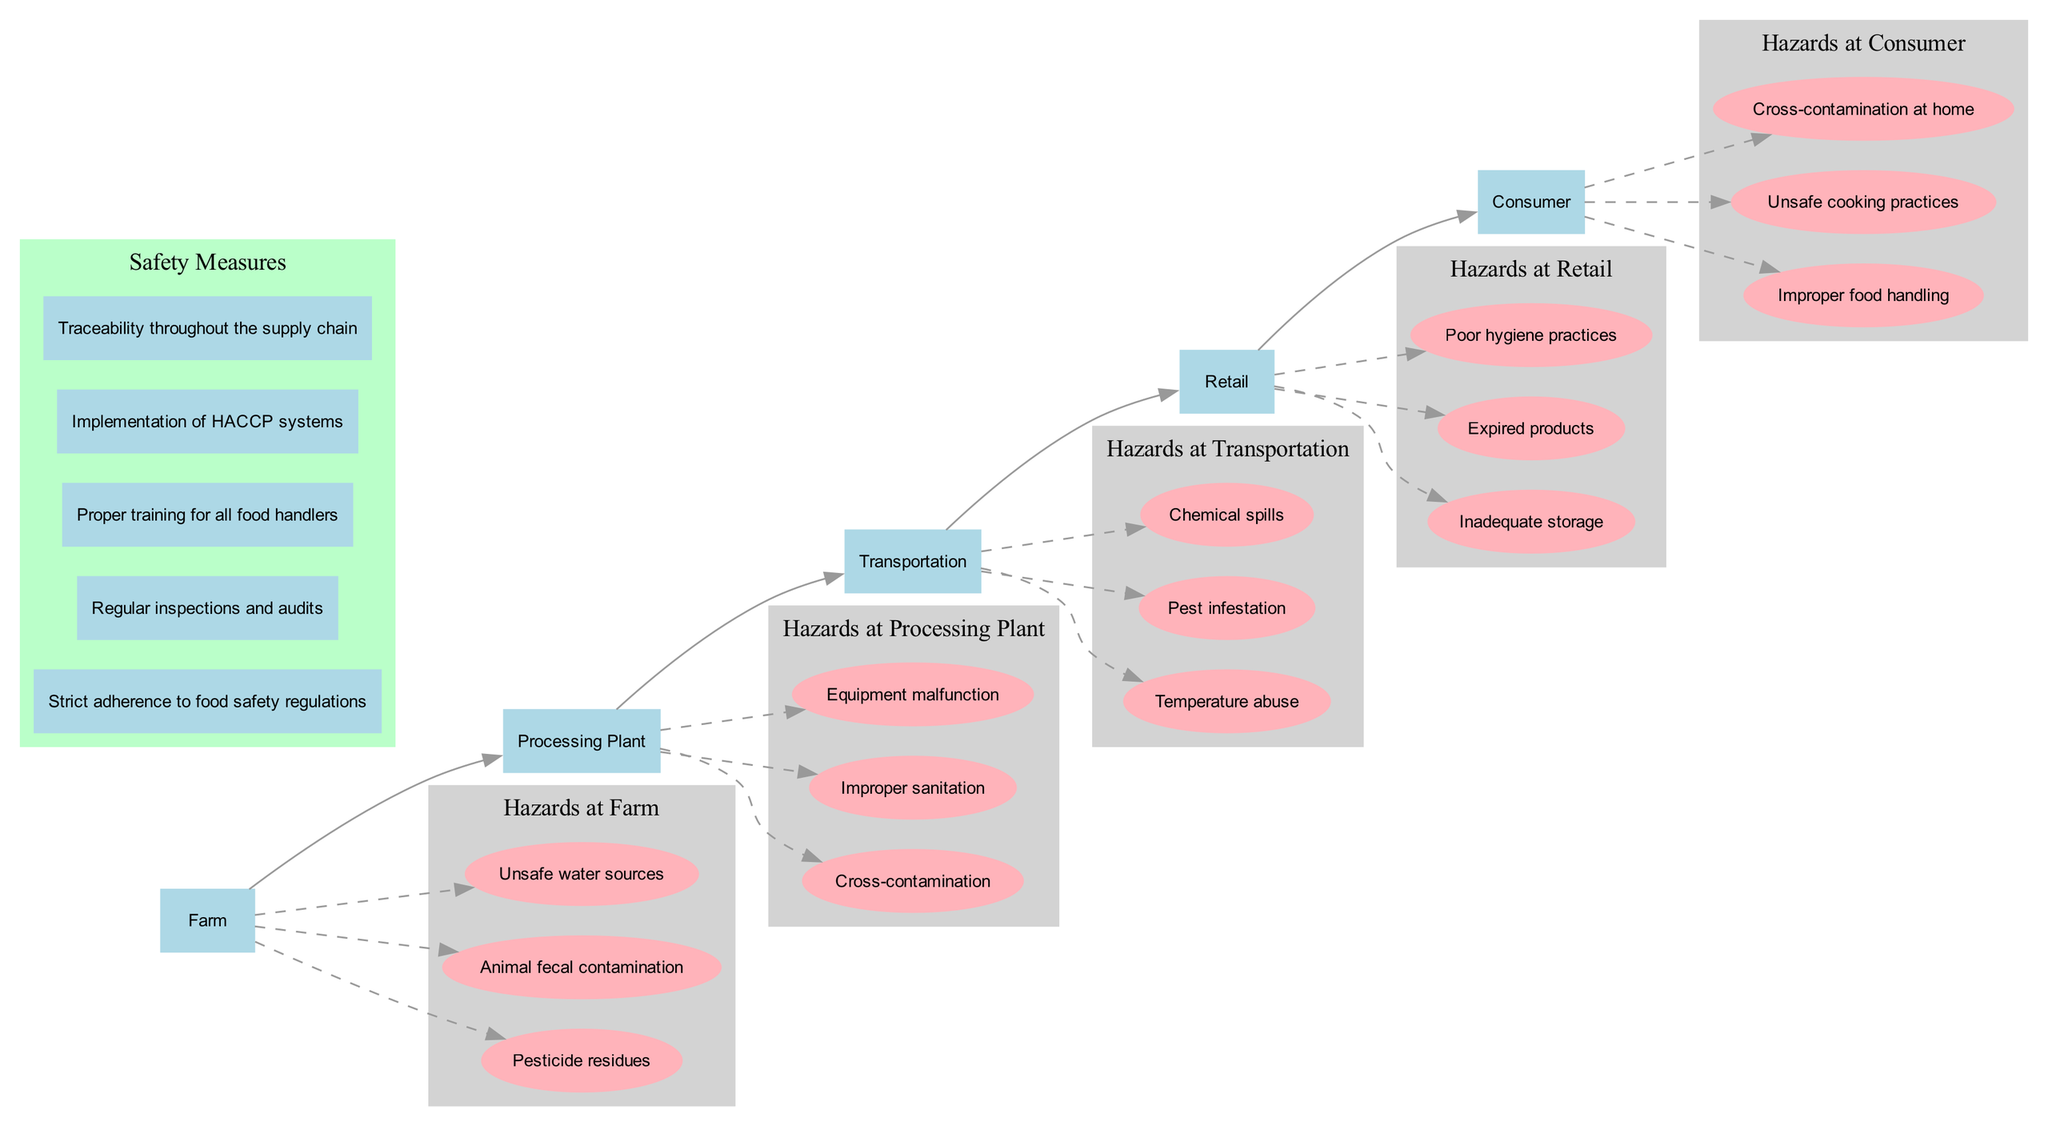What are the stages in the food supply chain? The diagram lists five stages of the food supply chain: Farm, Processing Plant, Transportation, Retail, and Consumer. These stages are shown in sequential order, representing the flow from production to consumption.
Answer: Farm, Processing Plant, Transportation, Retail, Consumer How many hazards are listed for the Transportation stage? There are three specific hazards associated with the Transportation stage: Temperature abuse, Pest infestation, and Chemical spills. The diagram clearly indicates these risks beneath the Transportation stage node.
Answer: Three What risk is associated with the Processing Plant stage? One of the highlighted risks for the Processing Plant stage is Cross-contamination. This hazard is outlined specifically as part of the processing risks.
Answer: Cross-contamination Which stage has the risk of Animal fecal contamination? The risk of Animal fecal contamination is identified as a hazard at the Farm stage, indicating contamination that may occur during the initial production of food.
Answer: Farm What is one safety measure mentioned in the diagram? One noted safety measure is "Strict adherence to food safety regulations." This measure is emphasized in a separate cluster labeled "Safety Measures" in the diagram.
Answer: Strict adherence to food safety regulations Are there any hazards listed for the Consumer stage? Yes, there are risks identified for the Consumer stage, including Improper food handling, Unsafe cooking practices, and Cross-contamination at home, indicating potential hazards at the final consumption point.
Answer: Yes What is the relationship between the stage of Retail and its risks? The Retail stage has three associated risks: Inadequate storage, Expired products, and Poor hygiene practices. These risks demonstrate how mishandling at this stage can compromise food safety before reaching consumers.
Answer: Retail has risks Which stage comes before the Processing Plant? The stage that precedes the Processing Plant is the Farm. In the diagram, arrows indicate the flow from the Farm directly into the Processing Plant, illustrating the food supply chain order.
Answer: Farm How are safety measures represented in the diagram? Safety measures are represented in a distinct subgraph labeled "Safety Measures" which contains several rectangle nodes, each listing different measures designed to enhance food safety throughout the supply chain.
Answer: Safety measures are in a subgraph 